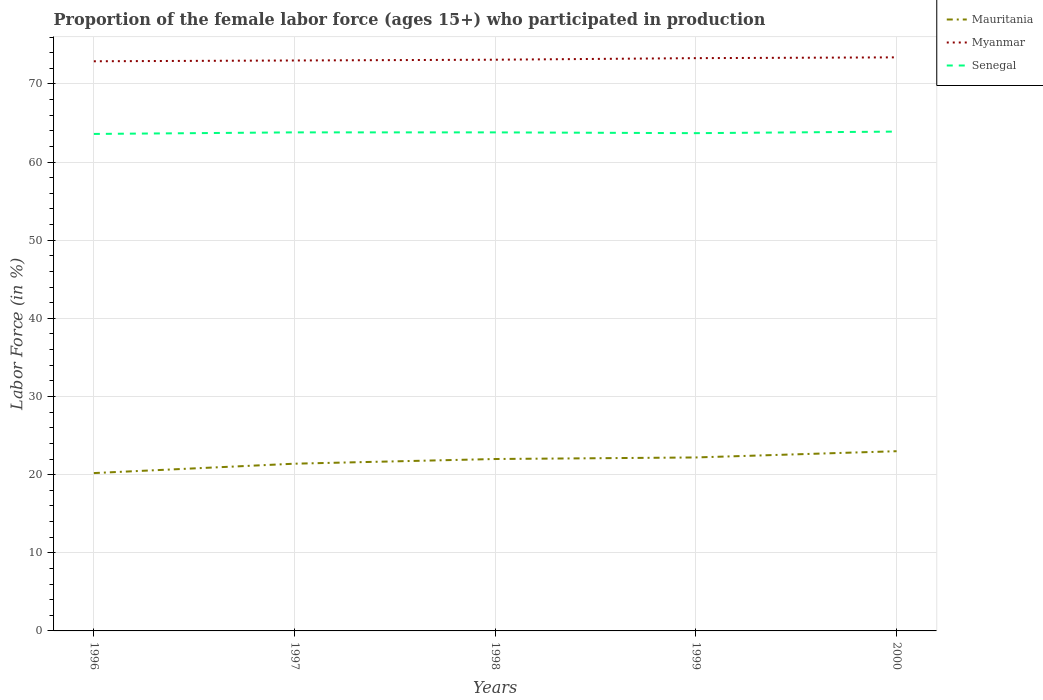How many different coloured lines are there?
Offer a very short reply. 3. Does the line corresponding to Mauritania intersect with the line corresponding to Myanmar?
Give a very brief answer. No. Is the number of lines equal to the number of legend labels?
Your answer should be compact. Yes. Across all years, what is the maximum proportion of the female labor force who participated in production in Mauritania?
Offer a very short reply. 20.2. What is the total proportion of the female labor force who participated in production in Senegal in the graph?
Keep it short and to the point. -0.3. What is the difference between the highest and the second highest proportion of the female labor force who participated in production in Mauritania?
Keep it short and to the point. 2.8. What is the difference between the highest and the lowest proportion of the female labor force who participated in production in Senegal?
Provide a short and direct response. 3. Is the proportion of the female labor force who participated in production in Senegal strictly greater than the proportion of the female labor force who participated in production in Myanmar over the years?
Ensure brevity in your answer.  Yes. What is the difference between two consecutive major ticks on the Y-axis?
Your response must be concise. 10. How many legend labels are there?
Offer a very short reply. 3. What is the title of the graph?
Your response must be concise. Proportion of the female labor force (ages 15+) who participated in production. What is the label or title of the X-axis?
Offer a very short reply. Years. What is the label or title of the Y-axis?
Provide a short and direct response. Labor Force (in %). What is the Labor Force (in %) of Mauritania in 1996?
Offer a terse response. 20.2. What is the Labor Force (in %) of Myanmar in 1996?
Ensure brevity in your answer.  72.9. What is the Labor Force (in %) in Senegal in 1996?
Give a very brief answer. 63.6. What is the Labor Force (in %) of Mauritania in 1997?
Make the answer very short. 21.4. What is the Labor Force (in %) of Senegal in 1997?
Your answer should be compact. 63.8. What is the Labor Force (in %) of Myanmar in 1998?
Ensure brevity in your answer.  73.1. What is the Labor Force (in %) of Senegal in 1998?
Ensure brevity in your answer.  63.8. What is the Labor Force (in %) in Mauritania in 1999?
Keep it short and to the point. 22.2. What is the Labor Force (in %) of Myanmar in 1999?
Ensure brevity in your answer.  73.3. What is the Labor Force (in %) of Senegal in 1999?
Your response must be concise. 63.7. What is the Labor Force (in %) of Mauritania in 2000?
Offer a very short reply. 23. What is the Labor Force (in %) in Myanmar in 2000?
Ensure brevity in your answer.  73.4. What is the Labor Force (in %) of Senegal in 2000?
Make the answer very short. 63.9. Across all years, what is the maximum Labor Force (in %) in Myanmar?
Offer a terse response. 73.4. Across all years, what is the maximum Labor Force (in %) of Senegal?
Ensure brevity in your answer.  63.9. Across all years, what is the minimum Labor Force (in %) of Mauritania?
Provide a short and direct response. 20.2. Across all years, what is the minimum Labor Force (in %) of Myanmar?
Offer a very short reply. 72.9. Across all years, what is the minimum Labor Force (in %) of Senegal?
Your answer should be compact. 63.6. What is the total Labor Force (in %) in Mauritania in the graph?
Provide a short and direct response. 108.8. What is the total Labor Force (in %) of Myanmar in the graph?
Provide a succinct answer. 365.7. What is the total Labor Force (in %) in Senegal in the graph?
Offer a very short reply. 318.8. What is the difference between the Labor Force (in %) of Myanmar in 1996 and that in 1997?
Keep it short and to the point. -0.1. What is the difference between the Labor Force (in %) in Senegal in 1996 and that in 1998?
Ensure brevity in your answer.  -0.2. What is the difference between the Labor Force (in %) in Mauritania in 1996 and that in 1999?
Keep it short and to the point. -2. What is the difference between the Labor Force (in %) in Myanmar in 1996 and that in 1999?
Ensure brevity in your answer.  -0.4. What is the difference between the Labor Force (in %) of Mauritania in 1997 and that in 1998?
Give a very brief answer. -0.6. What is the difference between the Labor Force (in %) of Myanmar in 1997 and that in 1998?
Your answer should be very brief. -0.1. What is the difference between the Labor Force (in %) in Senegal in 1997 and that in 1998?
Your answer should be compact. 0. What is the difference between the Labor Force (in %) in Mauritania in 1997 and that in 1999?
Give a very brief answer. -0.8. What is the difference between the Labor Force (in %) of Myanmar in 1997 and that in 2000?
Offer a terse response. -0.4. What is the difference between the Labor Force (in %) in Myanmar in 1998 and that in 1999?
Ensure brevity in your answer.  -0.2. What is the difference between the Labor Force (in %) in Mauritania in 1998 and that in 2000?
Make the answer very short. -1. What is the difference between the Labor Force (in %) of Senegal in 1998 and that in 2000?
Offer a terse response. -0.1. What is the difference between the Labor Force (in %) in Mauritania in 1996 and the Labor Force (in %) in Myanmar in 1997?
Your answer should be compact. -52.8. What is the difference between the Labor Force (in %) of Mauritania in 1996 and the Labor Force (in %) of Senegal in 1997?
Provide a succinct answer. -43.6. What is the difference between the Labor Force (in %) in Mauritania in 1996 and the Labor Force (in %) in Myanmar in 1998?
Your response must be concise. -52.9. What is the difference between the Labor Force (in %) in Mauritania in 1996 and the Labor Force (in %) in Senegal in 1998?
Offer a terse response. -43.6. What is the difference between the Labor Force (in %) of Myanmar in 1996 and the Labor Force (in %) of Senegal in 1998?
Make the answer very short. 9.1. What is the difference between the Labor Force (in %) of Mauritania in 1996 and the Labor Force (in %) of Myanmar in 1999?
Offer a very short reply. -53.1. What is the difference between the Labor Force (in %) of Mauritania in 1996 and the Labor Force (in %) of Senegal in 1999?
Your answer should be compact. -43.5. What is the difference between the Labor Force (in %) of Mauritania in 1996 and the Labor Force (in %) of Myanmar in 2000?
Give a very brief answer. -53.2. What is the difference between the Labor Force (in %) in Mauritania in 1996 and the Labor Force (in %) in Senegal in 2000?
Offer a terse response. -43.7. What is the difference between the Labor Force (in %) of Mauritania in 1997 and the Labor Force (in %) of Myanmar in 1998?
Your response must be concise. -51.7. What is the difference between the Labor Force (in %) in Mauritania in 1997 and the Labor Force (in %) in Senegal in 1998?
Offer a very short reply. -42.4. What is the difference between the Labor Force (in %) in Mauritania in 1997 and the Labor Force (in %) in Myanmar in 1999?
Offer a very short reply. -51.9. What is the difference between the Labor Force (in %) of Mauritania in 1997 and the Labor Force (in %) of Senegal in 1999?
Give a very brief answer. -42.3. What is the difference between the Labor Force (in %) of Myanmar in 1997 and the Labor Force (in %) of Senegal in 1999?
Keep it short and to the point. 9.3. What is the difference between the Labor Force (in %) of Mauritania in 1997 and the Labor Force (in %) of Myanmar in 2000?
Offer a terse response. -52. What is the difference between the Labor Force (in %) of Mauritania in 1997 and the Labor Force (in %) of Senegal in 2000?
Offer a terse response. -42.5. What is the difference between the Labor Force (in %) of Myanmar in 1997 and the Labor Force (in %) of Senegal in 2000?
Your answer should be very brief. 9.1. What is the difference between the Labor Force (in %) in Mauritania in 1998 and the Labor Force (in %) in Myanmar in 1999?
Keep it short and to the point. -51.3. What is the difference between the Labor Force (in %) of Mauritania in 1998 and the Labor Force (in %) of Senegal in 1999?
Provide a succinct answer. -41.7. What is the difference between the Labor Force (in %) of Myanmar in 1998 and the Labor Force (in %) of Senegal in 1999?
Provide a succinct answer. 9.4. What is the difference between the Labor Force (in %) of Mauritania in 1998 and the Labor Force (in %) of Myanmar in 2000?
Make the answer very short. -51.4. What is the difference between the Labor Force (in %) in Mauritania in 1998 and the Labor Force (in %) in Senegal in 2000?
Offer a terse response. -41.9. What is the difference between the Labor Force (in %) in Mauritania in 1999 and the Labor Force (in %) in Myanmar in 2000?
Keep it short and to the point. -51.2. What is the difference between the Labor Force (in %) in Mauritania in 1999 and the Labor Force (in %) in Senegal in 2000?
Offer a very short reply. -41.7. What is the average Labor Force (in %) of Mauritania per year?
Make the answer very short. 21.76. What is the average Labor Force (in %) in Myanmar per year?
Your response must be concise. 73.14. What is the average Labor Force (in %) of Senegal per year?
Make the answer very short. 63.76. In the year 1996, what is the difference between the Labor Force (in %) of Mauritania and Labor Force (in %) of Myanmar?
Provide a short and direct response. -52.7. In the year 1996, what is the difference between the Labor Force (in %) of Mauritania and Labor Force (in %) of Senegal?
Keep it short and to the point. -43.4. In the year 1996, what is the difference between the Labor Force (in %) of Myanmar and Labor Force (in %) of Senegal?
Provide a short and direct response. 9.3. In the year 1997, what is the difference between the Labor Force (in %) of Mauritania and Labor Force (in %) of Myanmar?
Offer a very short reply. -51.6. In the year 1997, what is the difference between the Labor Force (in %) in Mauritania and Labor Force (in %) in Senegal?
Ensure brevity in your answer.  -42.4. In the year 1998, what is the difference between the Labor Force (in %) in Mauritania and Labor Force (in %) in Myanmar?
Your answer should be compact. -51.1. In the year 1998, what is the difference between the Labor Force (in %) in Mauritania and Labor Force (in %) in Senegal?
Keep it short and to the point. -41.8. In the year 1998, what is the difference between the Labor Force (in %) in Myanmar and Labor Force (in %) in Senegal?
Make the answer very short. 9.3. In the year 1999, what is the difference between the Labor Force (in %) in Mauritania and Labor Force (in %) in Myanmar?
Your response must be concise. -51.1. In the year 1999, what is the difference between the Labor Force (in %) in Mauritania and Labor Force (in %) in Senegal?
Your answer should be compact. -41.5. In the year 1999, what is the difference between the Labor Force (in %) of Myanmar and Labor Force (in %) of Senegal?
Keep it short and to the point. 9.6. In the year 2000, what is the difference between the Labor Force (in %) in Mauritania and Labor Force (in %) in Myanmar?
Your answer should be very brief. -50.4. In the year 2000, what is the difference between the Labor Force (in %) in Mauritania and Labor Force (in %) in Senegal?
Your answer should be compact. -40.9. In the year 2000, what is the difference between the Labor Force (in %) in Myanmar and Labor Force (in %) in Senegal?
Your answer should be compact. 9.5. What is the ratio of the Labor Force (in %) of Mauritania in 1996 to that in 1997?
Offer a very short reply. 0.94. What is the ratio of the Labor Force (in %) in Mauritania in 1996 to that in 1998?
Your answer should be very brief. 0.92. What is the ratio of the Labor Force (in %) of Mauritania in 1996 to that in 1999?
Offer a very short reply. 0.91. What is the ratio of the Labor Force (in %) in Myanmar in 1996 to that in 1999?
Your answer should be very brief. 0.99. What is the ratio of the Labor Force (in %) of Mauritania in 1996 to that in 2000?
Provide a succinct answer. 0.88. What is the ratio of the Labor Force (in %) of Myanmar in 1996 to that in 2000?
Provide a short and direct response. 0.99. What is the ratio of the Labor Force (in %) in Senegal in 1996 to that in 2000?
Your answer should be very brief. 1. What is the ratio of the Labor Force (in %) of Mauritania in 1997 to that in 1998?
Your answer should be very brief. 0.97. What is the ratio of the Labor Force (in %) of Senegal in 1997 to that in 1998?
Your answer should be very brief. 1. What is the ratio of the Labor Force (in %) in Mauritania in 1997 to that in 2000?
Provide a succinct answer. 0.93. What is the ratio of the Labor Force (in %) in Myanmar in 1997 to that in 2000?
Your response must be concise. 0.99. What is the ratio of the Labor Force (in %) of Senegal in 1997 to that in 2000?
Your answer should be very brief. 1. What is the ratio of the Labor Force (in %) of Mauritania in 1998 to that in 1999?
Ensure brevity in your answer.  0.99. What is the ratio of the Labor Force (in %) in Mauritania in 1998 to that in 2000?
Provide a short and direct response. 0.96. What is the ratio of the Labor Force (in %) in Myanmar in 1998 to that in 2000?
Provide a short and direct response. 1. What is the ratio of the Labor Force (in %) of Senegal in 1998 to that in 2000?
Your answer should be compact. 1. What is the ratio of the Labor Force (in %) of Mauritania in 1999 to that in 2000?
Make the answer very short. 0.97. What is the ratio of the Labor Force (in %) in Senegal in 1999 to that in 2000?
Give a very brief answer. 1. What is the difference between the highest and the lowest Labor Force (in %) of Mauritania?
Make the answer very short. 2.8. What is the difference between the highest and the lowest Labor Force (in %) in Senegal?
Keep it short and to the point. 0.3. 